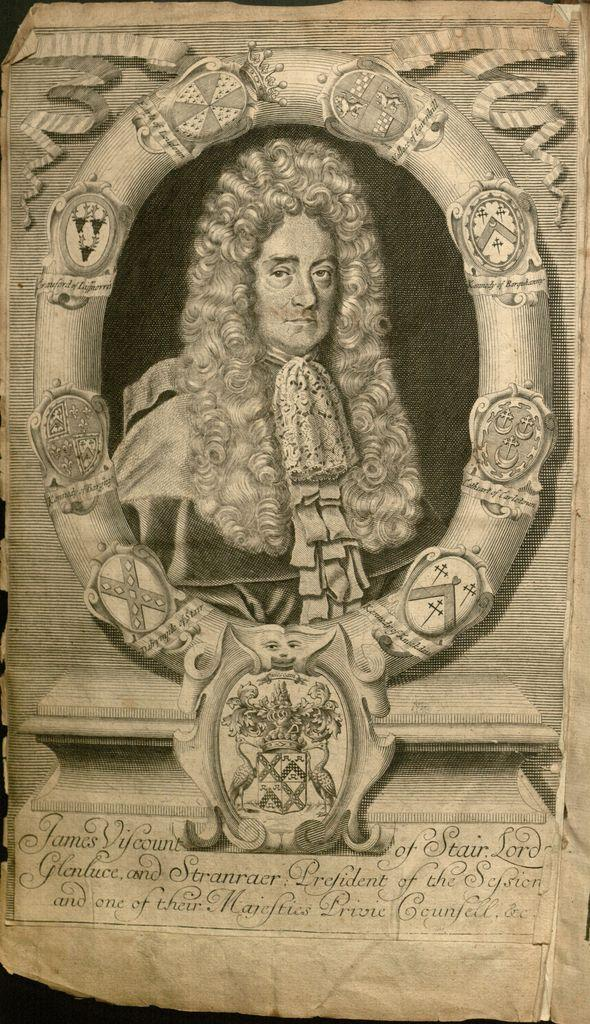What is the main subject of the image within the image? The main subject of the image within the image is a person. How is the person represented in the image? The person is represented as an image on a piece of paper. Is there any text accompanying the image of the person? Yes, there is some text present on the paper. How many bikes are parked next to the person in the image? There are no bikes present in the image; it only contains a paper with an image of a person and some text. 